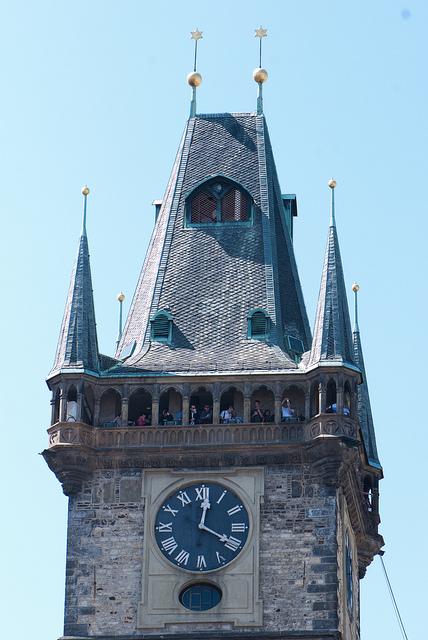What time is it?
Quick response, please. 12:20. What color are the balls on the top of the steeple?
Short answer required. Gold. Is this a sunny day?
Short answer required. Yes. 